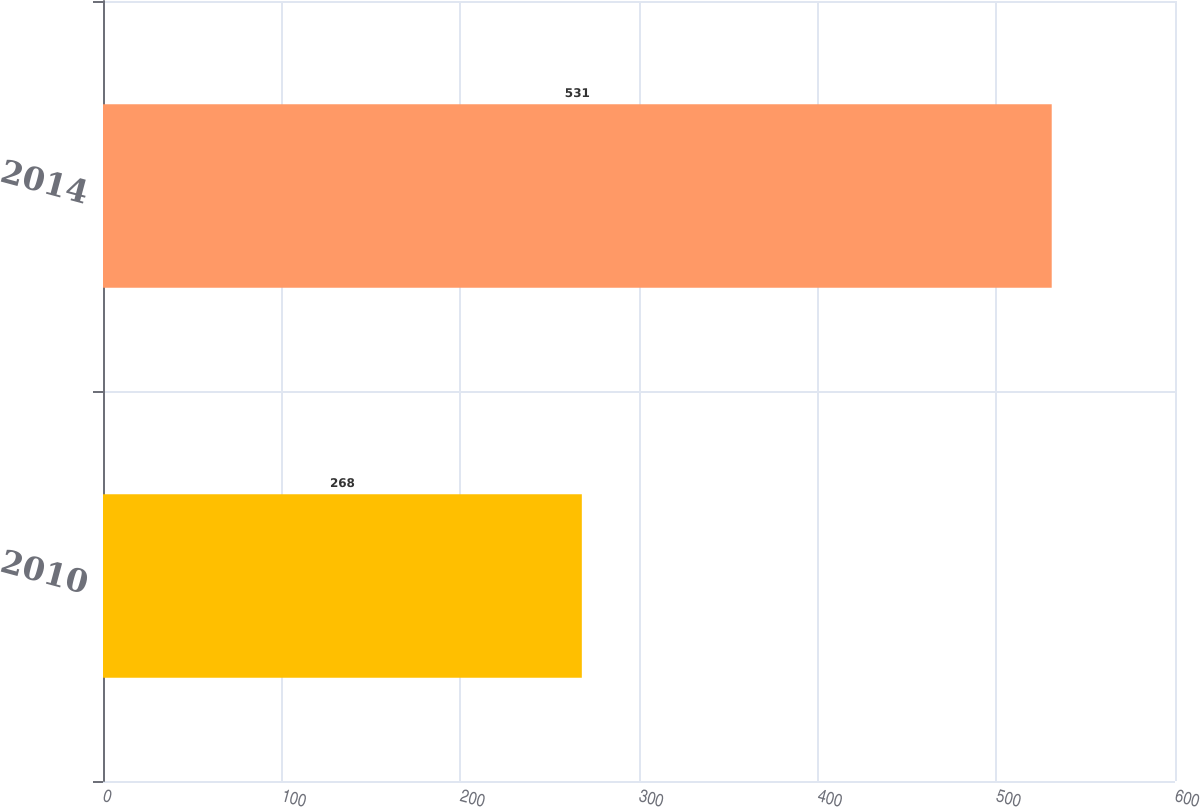<chart> <loc_0><loc_0><loc_500><loc_500><bar_chart><fcel>2010<fcel>2014<nl><fcel>268<fcel>531<nl></chart> 